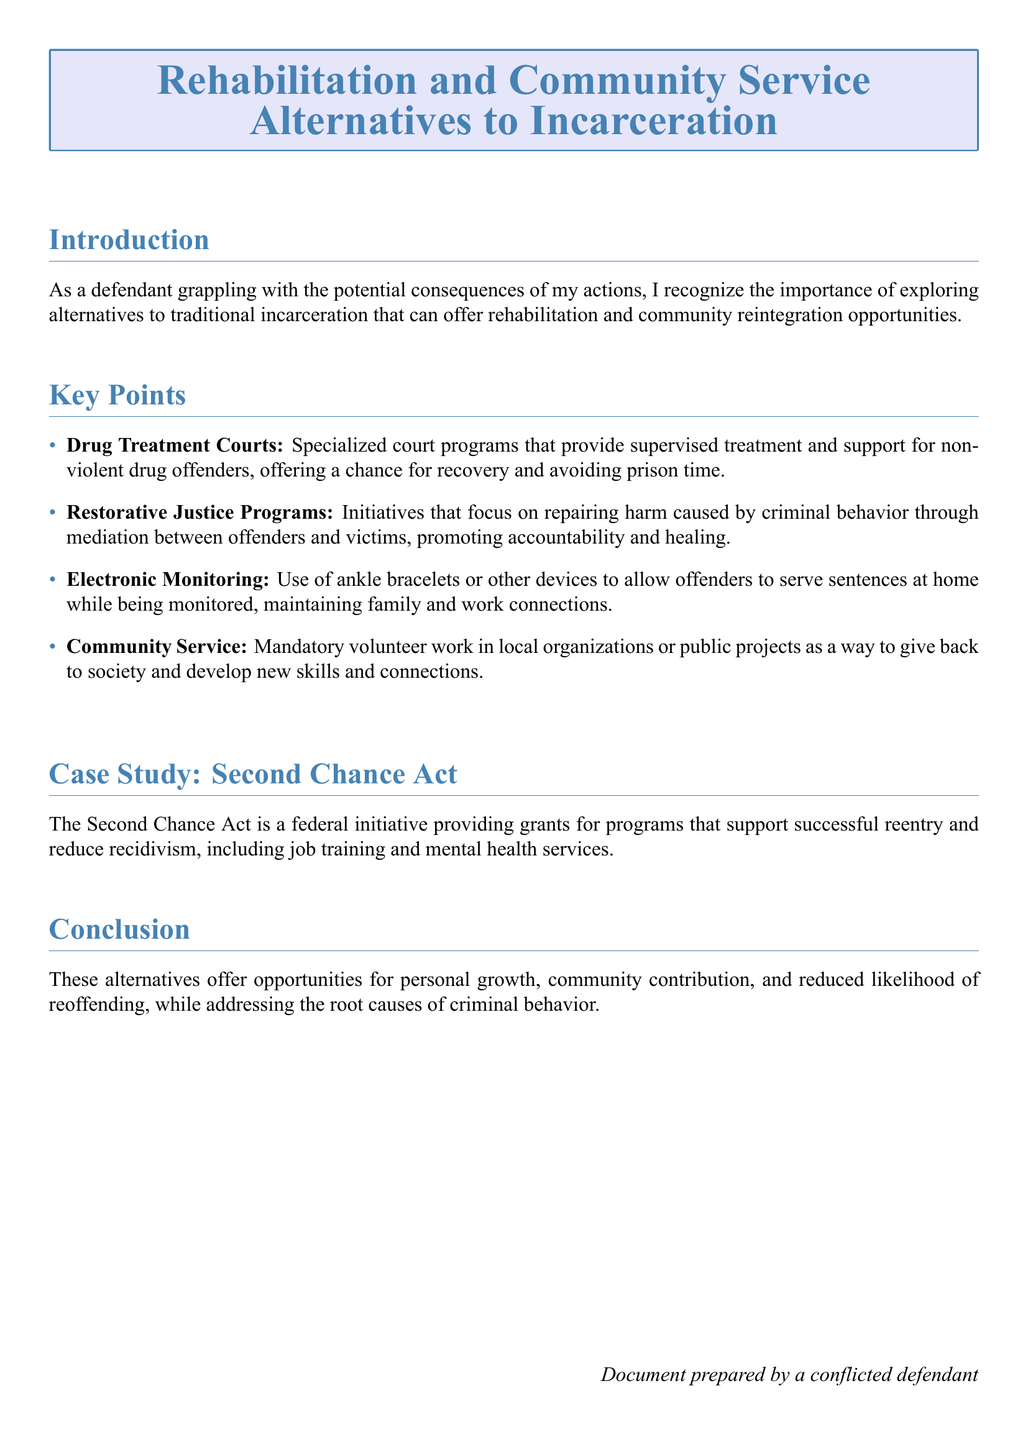What is the main focus of the document? The document focuses on exploring alternatives to traditional incarceration that offer rehabilitation and community reintegration opportunities.
Answer: Rehabilitation and community reintegration What is one type of specialized court program mentioned? The document mentions Drug Treatment Courts as specialized programs for non-violent drug offenders.
Answer: Drug Treatment Courts What does community service involve? Community service involves mandatory volunteer work in local organizations or public projects.
Answer: Mandatory volunteer work What initiative provides grants for successful reentry programs? The document states that the Second Chance Act is a federal initiative providing grants.
Answer: Second Chance Act What type of monitoring allows offenders to serve sentences at home? The document refers to Electronic Monitoring as a method for home confinement.
Answer: Electronic Monitoring What type of programs promote accountability and healing? Restorative Justice Programs are mentioned as focusing on accountability and healing.
Answer: Restorative Justice Programs How does the document suggest addressing the root causes of criminal behavior? The document discusses alternatives that promote personal growth and community contribution to address root causes.
Answer: Personal growth and community contribution What two services does the Second Chance Act support? The document mentions job training and mental health services as supports under the Second Chance Act.
Answer: Job training and mental health services 